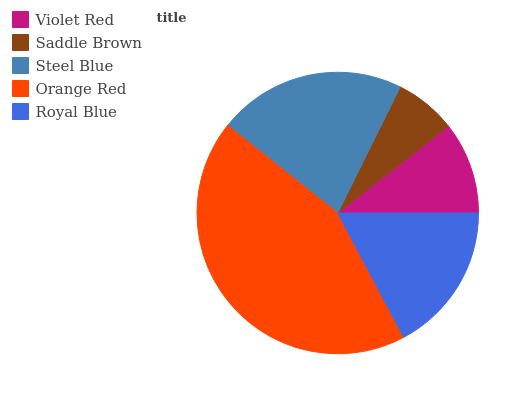Is Saddle Brown the minimum?
Answer yes or no. Yes. Is Orange Red the maximum?
Answer yes or no. Yes. Is Steel Blue the minimum?
Answer yes or no. No. Is Steel Blue the maximum?
Answer yes or no. No. Is Steel Blue greater than Saddle Brown?
Answer yes or no. Yes. Is Saddle Brown less than Steel Blue?
Answer yes or no. Yes. Is Saddle Brown greater than Steel Blue?
Answer yes or no. No. Is Steel Blue less than Saddle Brown?
Answer yes or no. No. Is Royal Blue the high median?
Answer yes or no. Yes. Is Royal Blue the low median?
Answer yes or no. Yes. Is Steel Blue the high median?
Answer yes or no. No. Is Orange Red the low median?
Answer yes or no. No. 